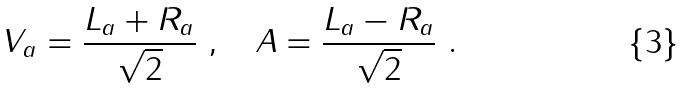<formula> <loc_0><loc_0><loc_500><loc_500>V _ { a } = \frac { L _ { a } + R _ { a } } { \sqrt { 2 } } \ , \quad A = \frac { L _ { a } - R _ { a } } { \sqrt { 2 } } \ .</formula> 